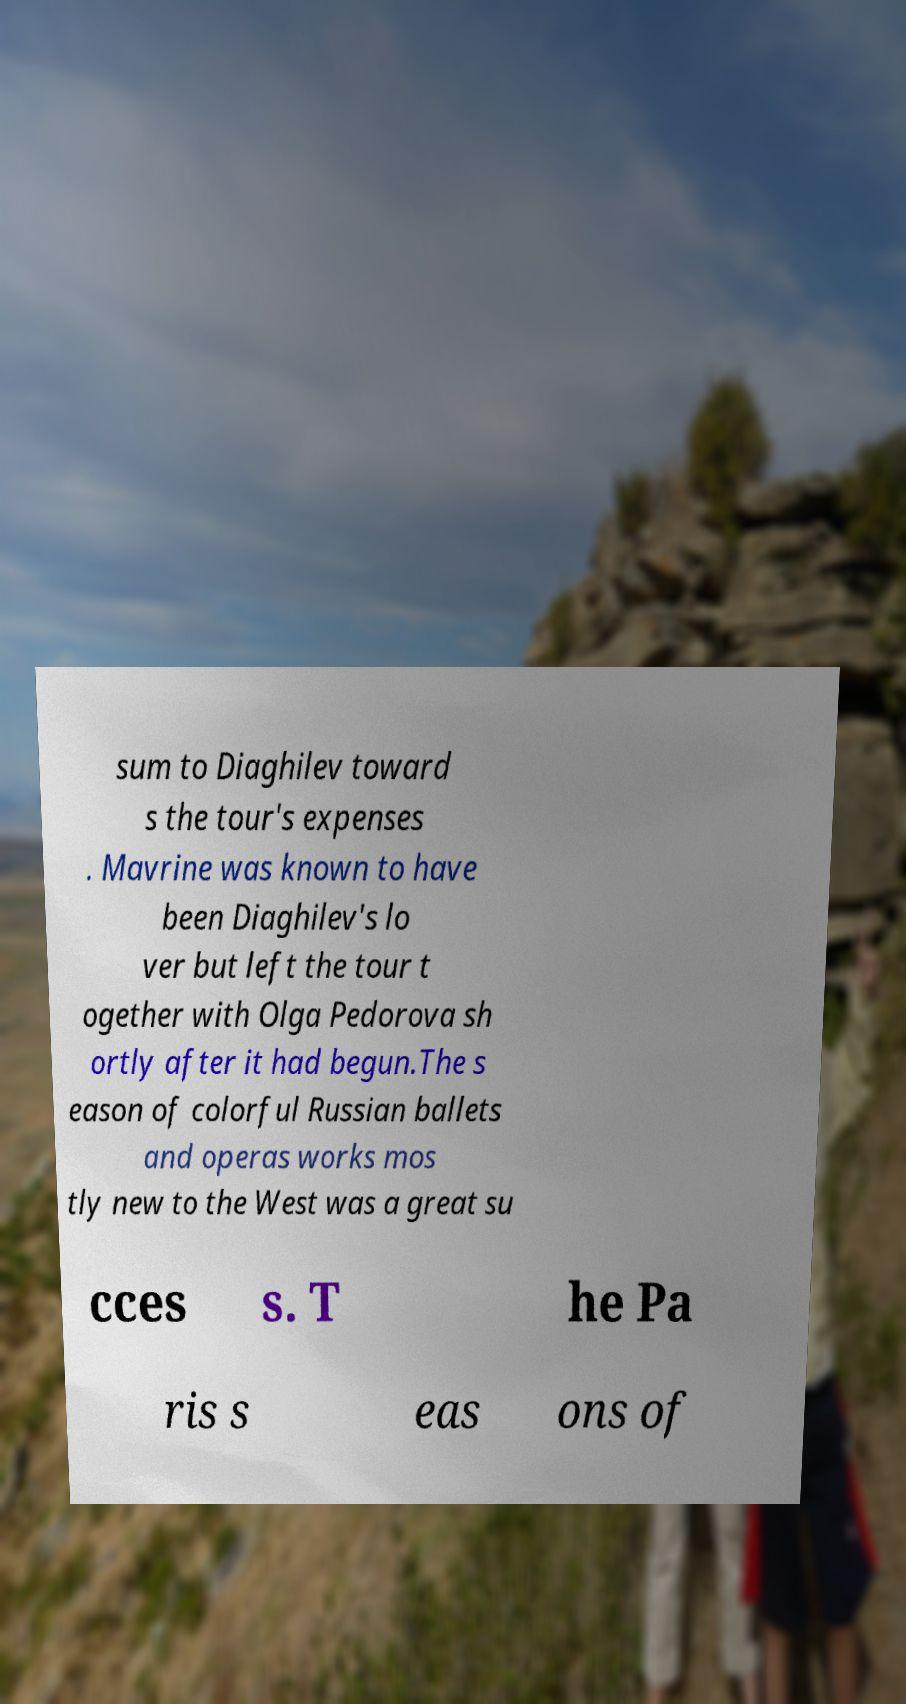There's text embedded in this image that I need extracted. Can you transcribe it verbatim? sum to Diaghilev toward s the tour's expenses . Mavrine was known to have been Diaghilev's lo ver but left the tour t ogether with Olga Pedorova sh ortly after it had begun.The s eason of colorful Russian ballets and operas works mos tly new to the West was a great su cces s. T he Pa ris s eas ons of 